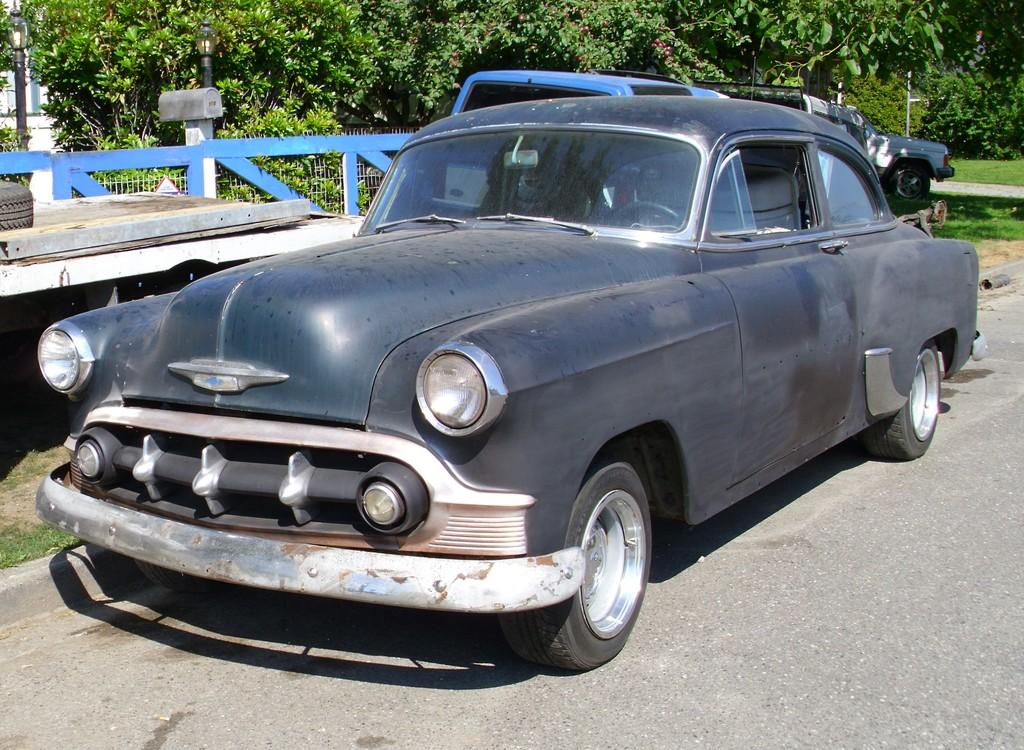What is the main subject of the image? The main subject of the image is a group of vehicles on the road. What can be seen in the background of the image? In the background of the image, there is a fence and trees. What type of flag is being waved by the vehicles in the image? There is no flag being waved by the vehicles in the image; the image only shows a group of vehicles on the road with a fence and trees in the background. 